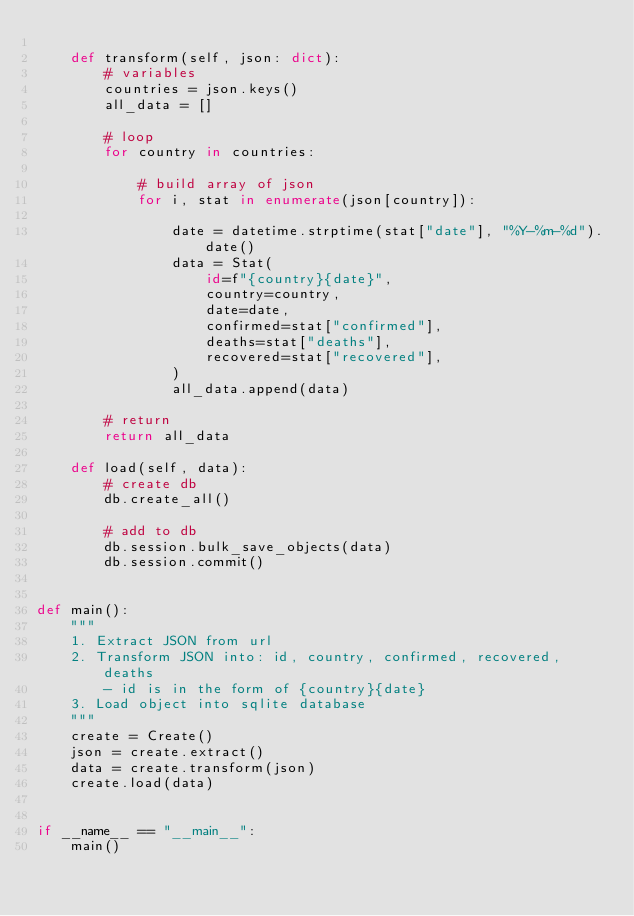<code> <loc_0><loc_0><loc_500><loc_500><_Python_>
    def transform(self, json: dict):
        # variables
        countries = json.keys()
        all_data = []

        # loop
        for country in countries:

            # build array of json
            for i, stat in enumerate(json[country]):

                date = datetime.strptime(stat["date"], "%Y-%m-%d").date()
                data = Stat(
                    id=f"{country}{date}",
                    country=country,
                    date=date,
                    confirmed=stat["confirmed"],
                    deaths=stat["deaths"],
                    recovered=stat["recovered"],
                )
                all_data.append(data)

        # return
        return all_data

    def load(self, data):
        # create db
        db.create_all()

        # add to db
        db.session.bulk_save_objects(data)
        db.session.commit()


def main():
    """
    1. Extract JSON from url
    2. Transform JSON into: id, country, confirmed, recovered, deaths
        - id is in the form of {country}{date}
    3. Load object into sqlite database
    """
    create = Create()
    json = create.extract()
    data = create.transform(json)
    create.load(data)


if __name__ == "__main__":
    main()
</code> 